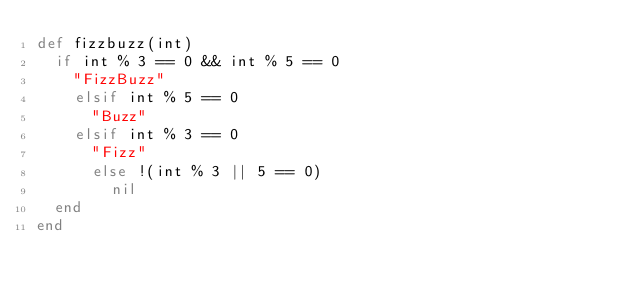<code> <loc_0><loc_0><loc_500><loc_500><_Ruby_>def fizzbuzz(int)
  if int % 3 == 0 && int % 5 == 0
    "FizzBuzz"
    elsif int % 5 == 0
      "Buzz"
    elsif int % 3 == 0
      "Fizz"
      else !(int % 3 || 5 == 0)
        nil
  end
end</code> 